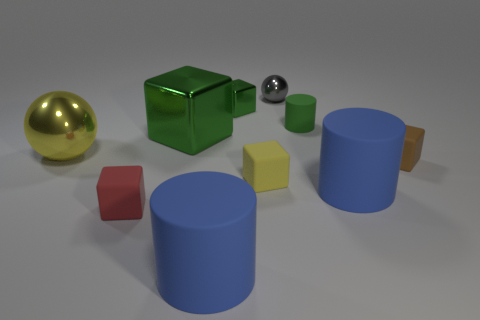Subtract all tiny yellow rubber blocks. How many blocks are left? 4 Subtract all gray balls. How many brown cubes are left? 1 Subtract all red cubes. Subtract all small matte objects. How many objects are left? 5 Add 5 blue rubber cylinders. How many blue rubber cylinders are left? 7 Add 2 green spheres. How many green spheres exist? 2 Subtract all yellow balls. How many balls are left? 1 Subtract 0 yellow cylinders. How many objects are left? 10 Subtract all cylinders. How many objects are left? 7 Subtract 1 spheres. How many spheres are left? 1 Subtract all brown cylinders. Subtract all brown cubes. How many cylinders are left? 3 